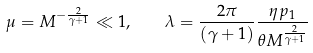Convert formula to latex. <formula><loc_0><loc_0><loc_500><loc_500>\mu = M ^ { - \frac { 2 } { \gamma + 1 } } \ll 1 , \quad \lambda = \frac { 2 \pi } { ( \gamma + 1 ) } \frac { \eta p _ { 1 } } { \theta M ^ { \frac { 2 } { \gamma + 1 } } }</formula> 